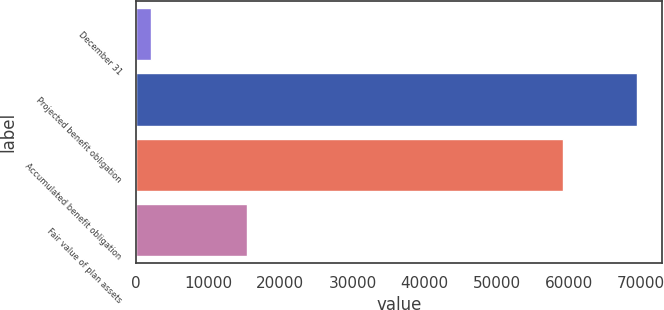<chart> <loc_0><loc_0><loc_500><loc_500><bar_chart><fcel>December 31<fcel>Projected benefit obligation<fcel>Accumulated benefit obligation<fcel>Fair value of plan assets<nl><fcel>2009<fcel>69482<fcel>59246<fcel>15354<nl></chart> 